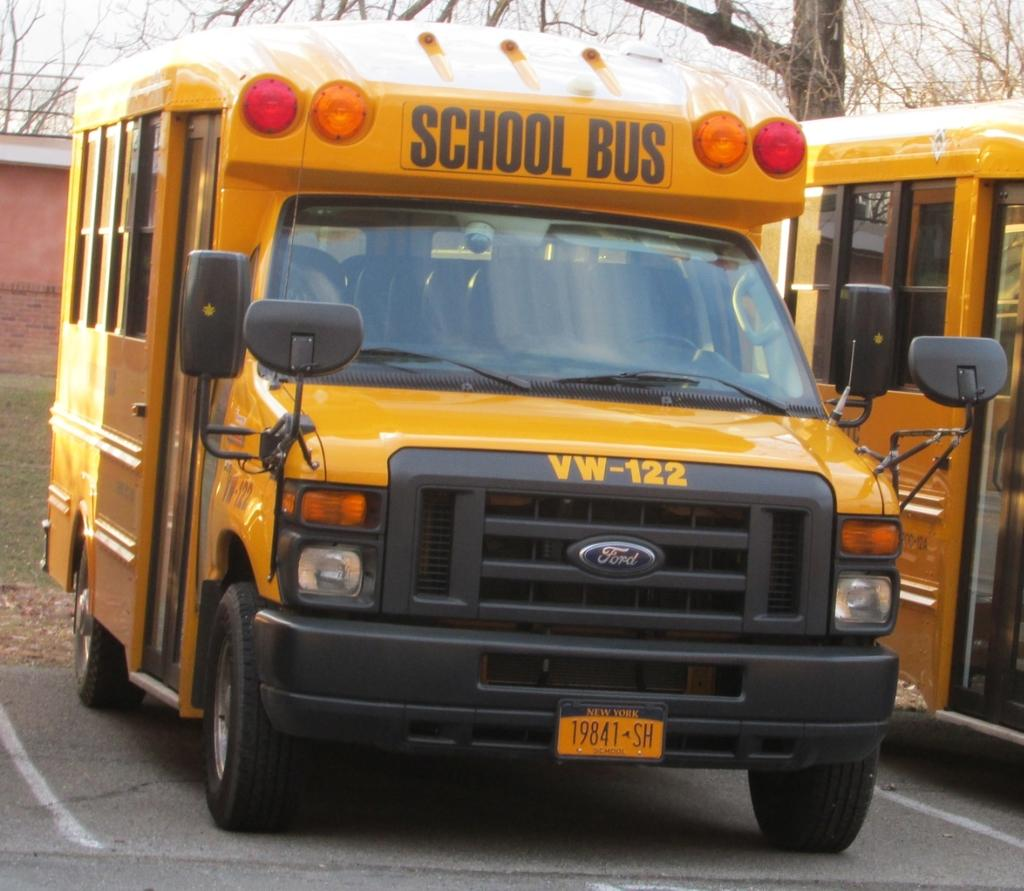Provide a one-sentence caption for the provided image. Schoolbus with the license plate "VW-122", parked in a parking lot. 